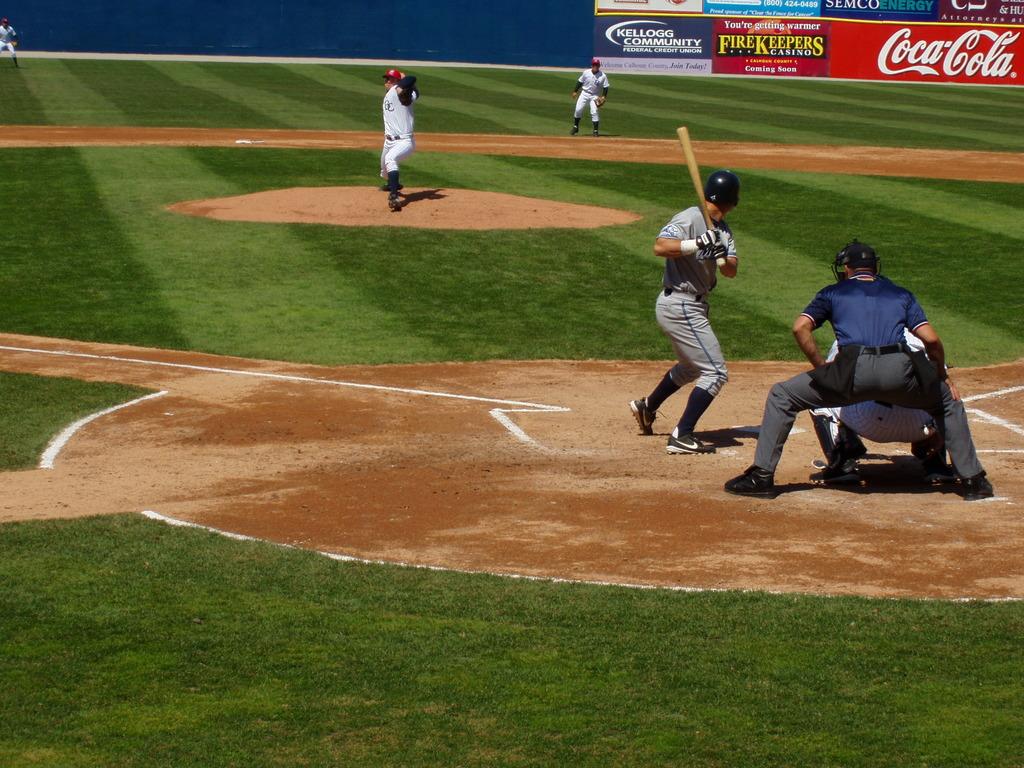What soda brand sponsors this ballpark?
Give a very brief answer. Coca cola. 